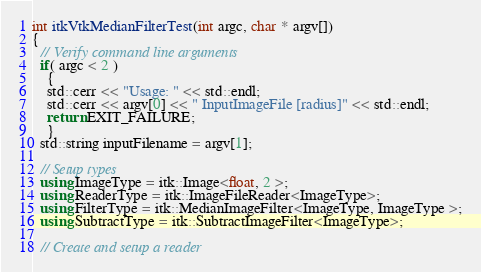Convert code to text. <code><loc_0><loc_0><loc_500><loc_500><_C++_>int itkVtkMedianFilterTest(int argc, char * argv[])
{
  // Verify command line arguments
  if( argc < 2 )
    {
    std::cerr << "Usage: " << std::endl;
    std::cerr << argv[0] << " InputImageFile [radius]" << std::endl;
    return EXIT_FAILURE;
    }
  std::string inputFilename = argv[1];

  // Setup types
  using ImageType = itk::Image<float, 2 >;
  using ReaderType = itk::ImageFileReader<ImageType>;
  using FilterType = itk::MedianImageFilter<ImageType, ImageType >;
  using SubtractType = itk::SubtractImageFilter<ImageType>;

  // Create and setup a reader</code> 